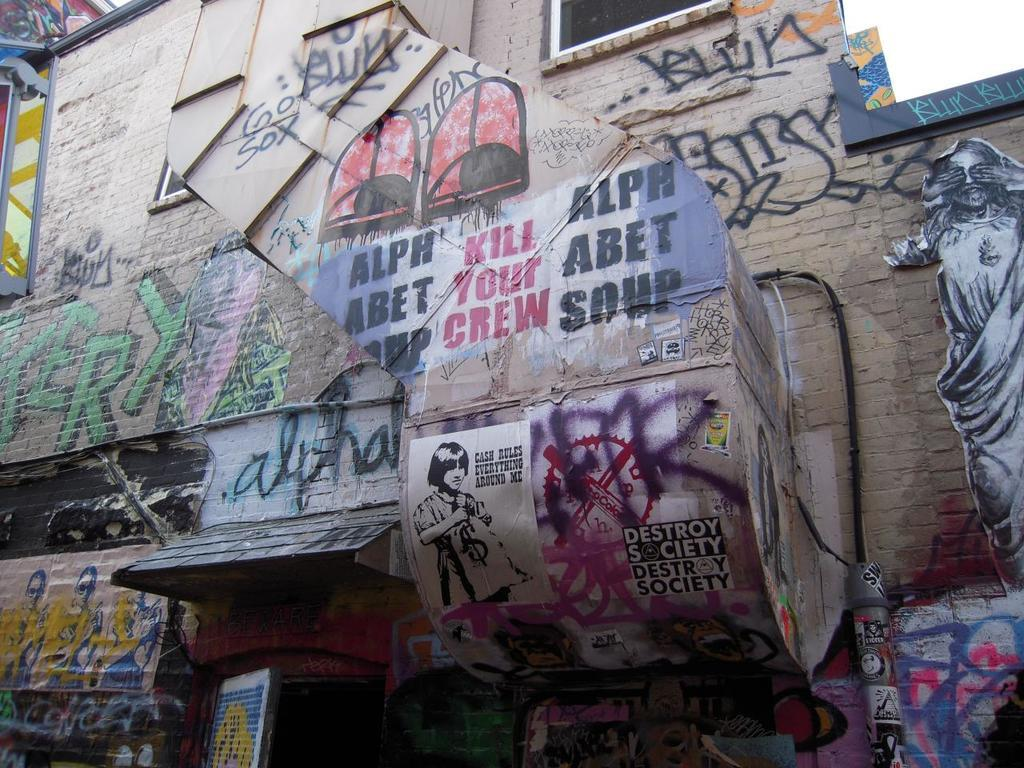What can be seen on the wall in the image? There is graffiti and posters of people on the wall in the image. What else is visible in the image besides the wall? There is a door visible in the image. What type of country is depicted in the graffiti on the wall? There is no country depicted in the graffiti on the wall; it is an abstract design or image. 